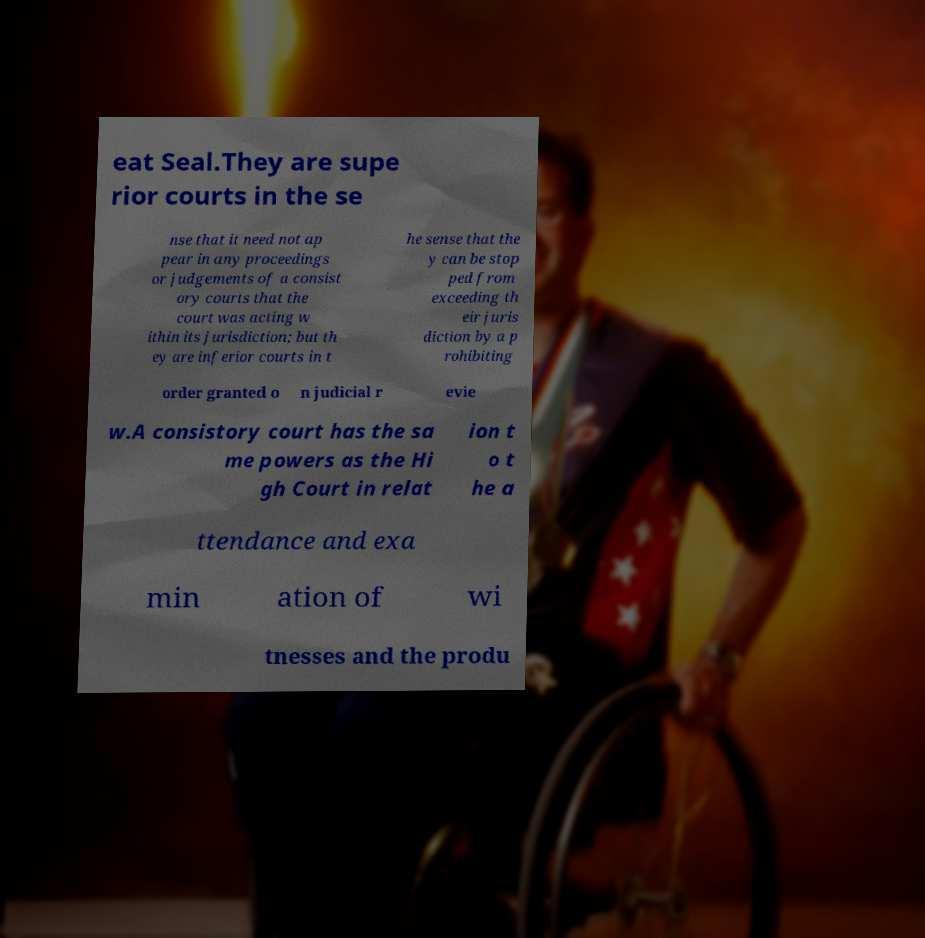What messages or text are displayed in this image? I need them in a readable, typed format. eat Seal.They are supe rior courts in the se nse that it need not ap pear in any proceedings or judgements of a consist ory courts that the court was acting w ithin its jurisdiction; but th ey are inferior courts in t he sense that the y can be stop ped from exceeding th eir juris diction by a p rohibiting order granted o n judicial r evie w.A consistory court has the sa me powers as the Hi gh Court in relat ion t o t he a ttendance and exa min ation of wi tnesses and the produ 